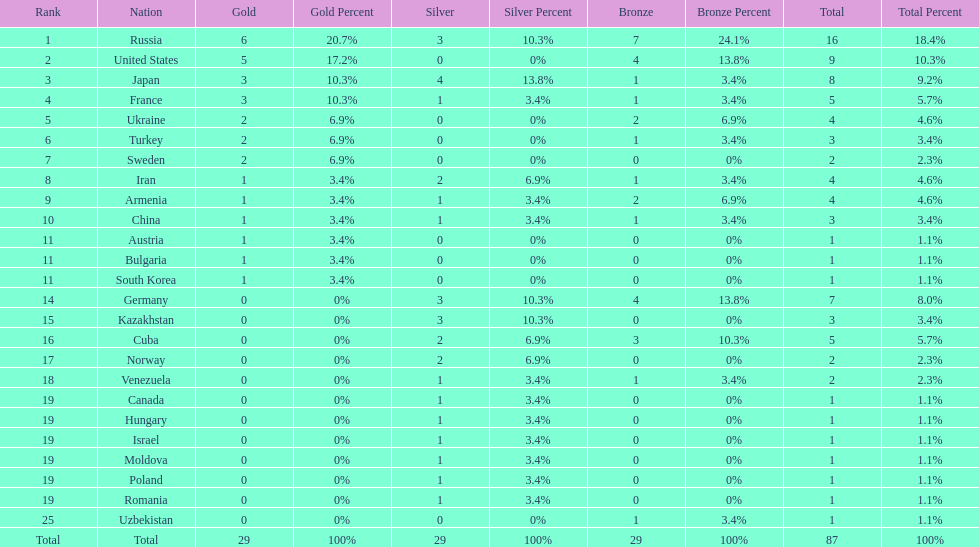Who ranked right after turkey? Sweden. 